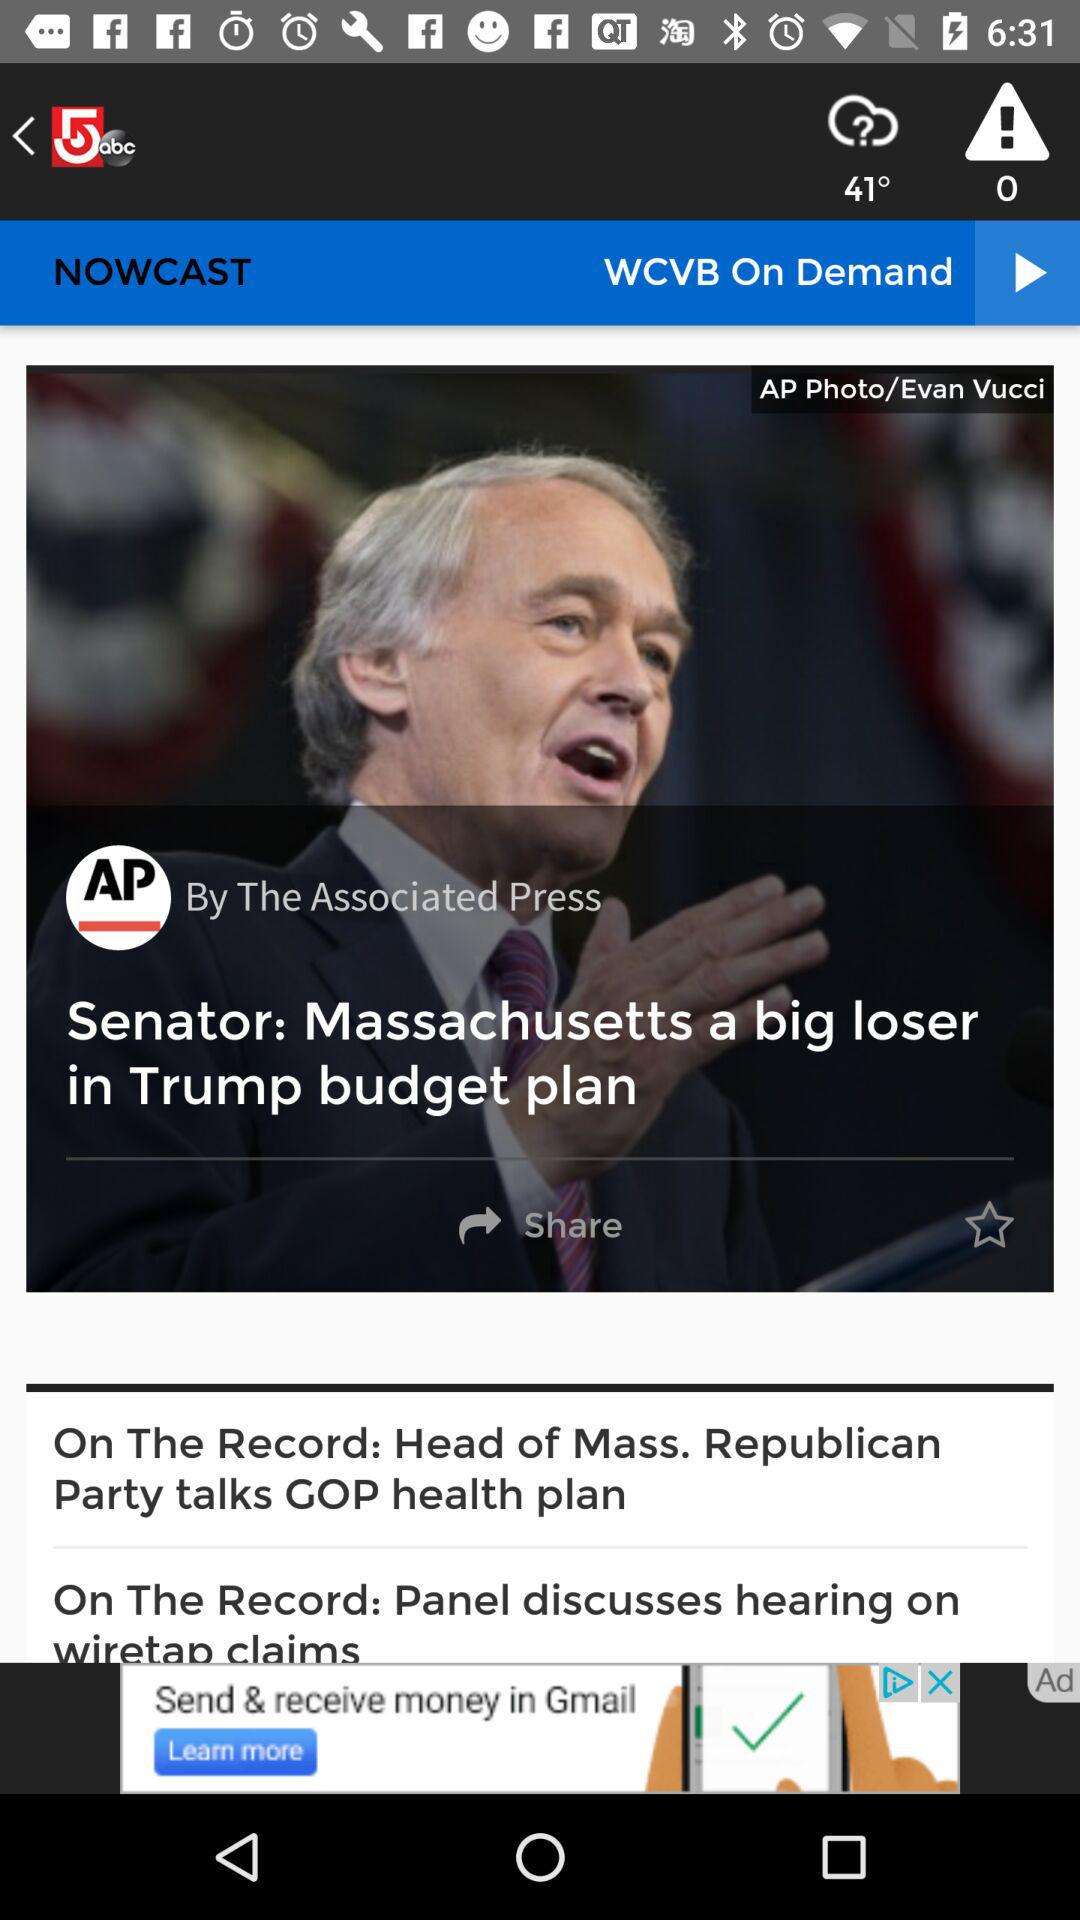What's the news agency's name? The news agency's name is "The Associated Press". 